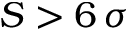<formula> <loc_0><loc_0><loc_500><loc_500>S > 6 \, \sigma</formula> 